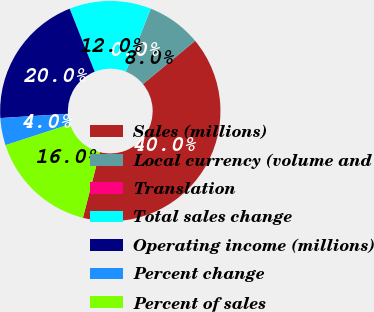<chart> <loc_0><loc_0><loc_500><loc_500><pie_chart><fcel>Sales (millions)<fcel>Local currency (volume and<fcel>Translation<fcel>Total sales change<fcel>Operating income (millions)<fcel>Percent change<fcel>Percent of sales<nl><fcel>40.0%<fcel>8.0%<fcel>0.0%<fcel>12.0%<fcel>20.0%<fcel>4.0%<fcel>16.0%<nl></chart> 